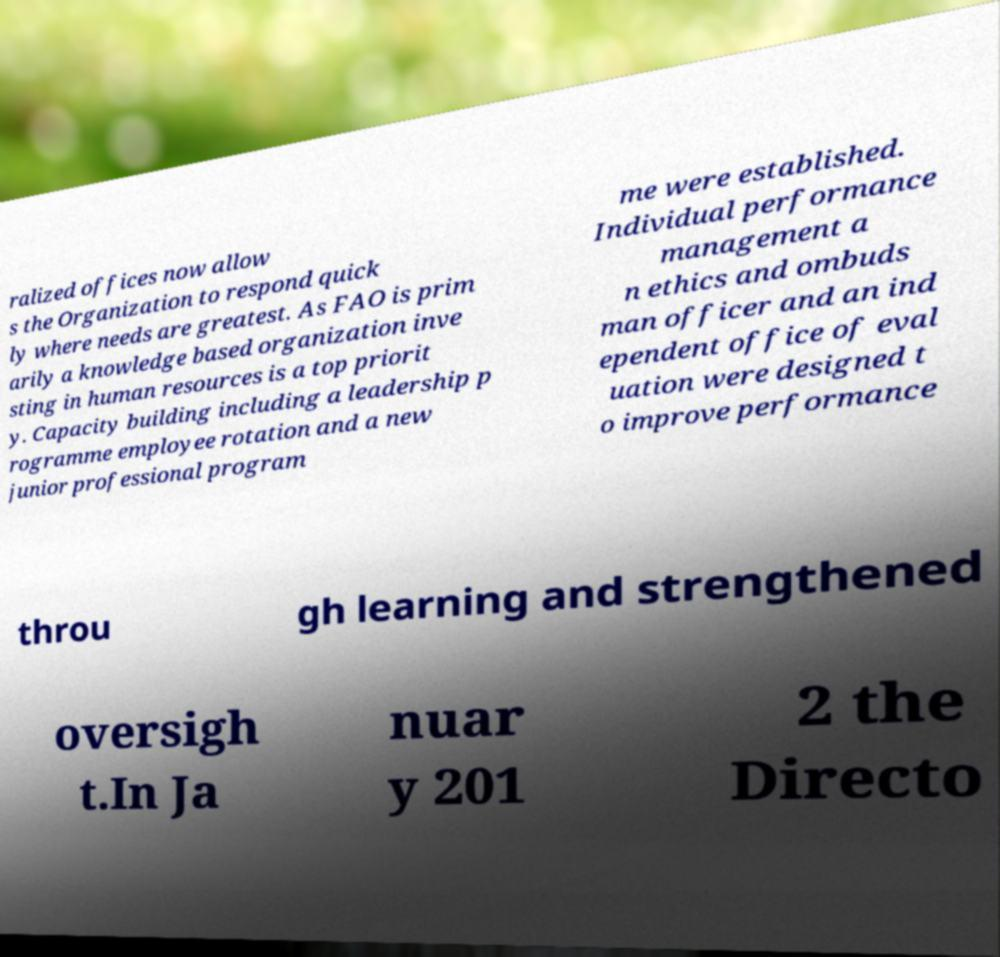Please identify and transcribe the text found in this image. ralized offices now allow s the Organization to respond quick ly where needs are greatest. As FAO is prim arily a knowledge based organization inve sting in human resources is a top priorit y. Capacity building including a leadership p rogramme employee rotation and a new junior professional program me were established. Individual performance management a n ethics and ombuds man officer and an ind ependent office of eval uation were designed t o improve performance throu gh learning and strengthened oversigh t.In Ja nuar y 201 2 the Directo 